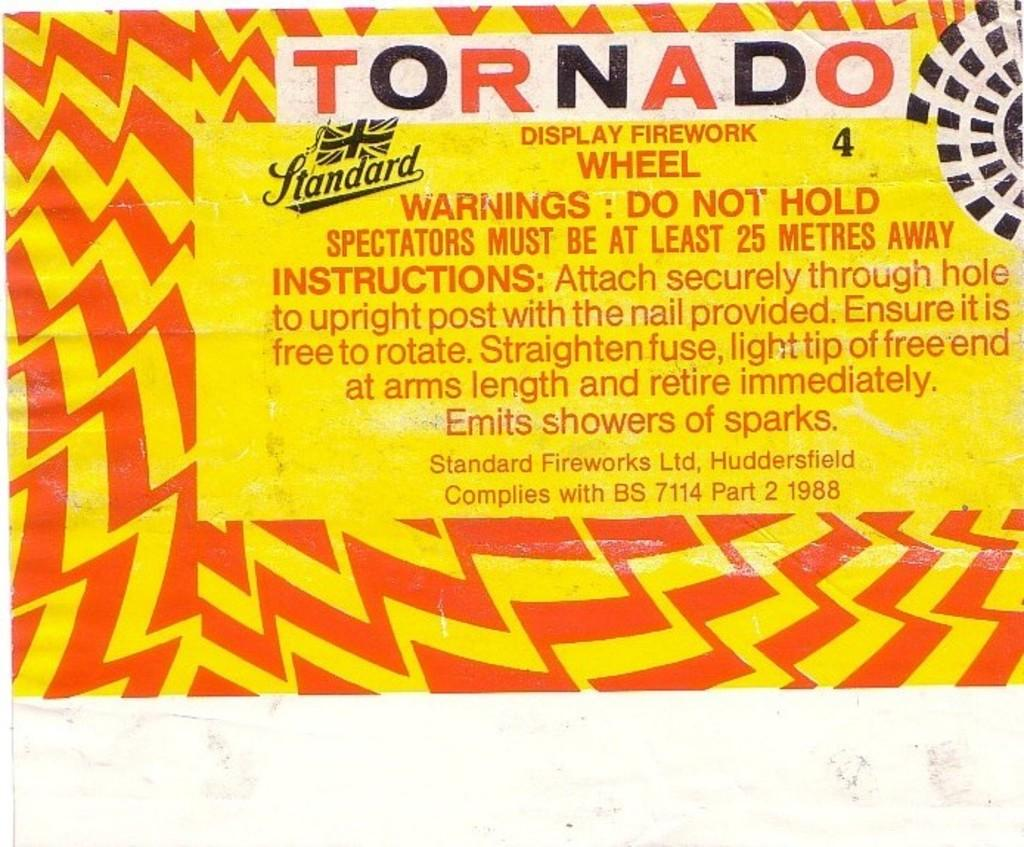What is the main subject of the image? The main subject of the image is an advertisement. What type of fork is being used by the porter in the image? There is no fork or porter present in the image; it only features an advertisement. 